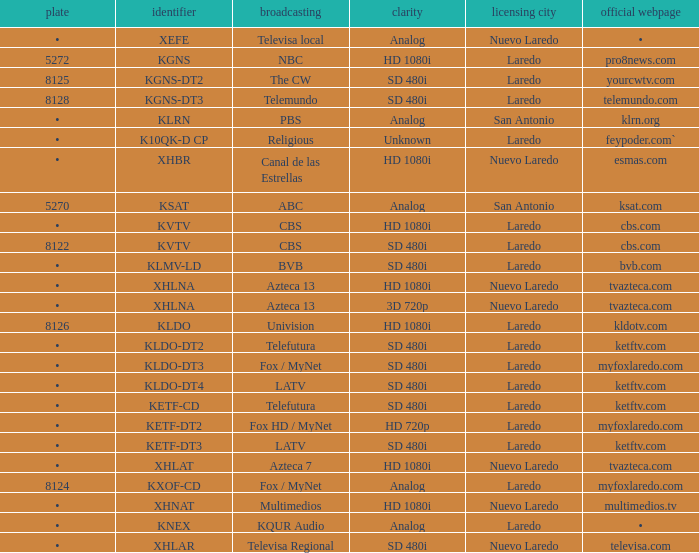Name the official website which has dish of • and callsign of kvtv Cbs.com. 